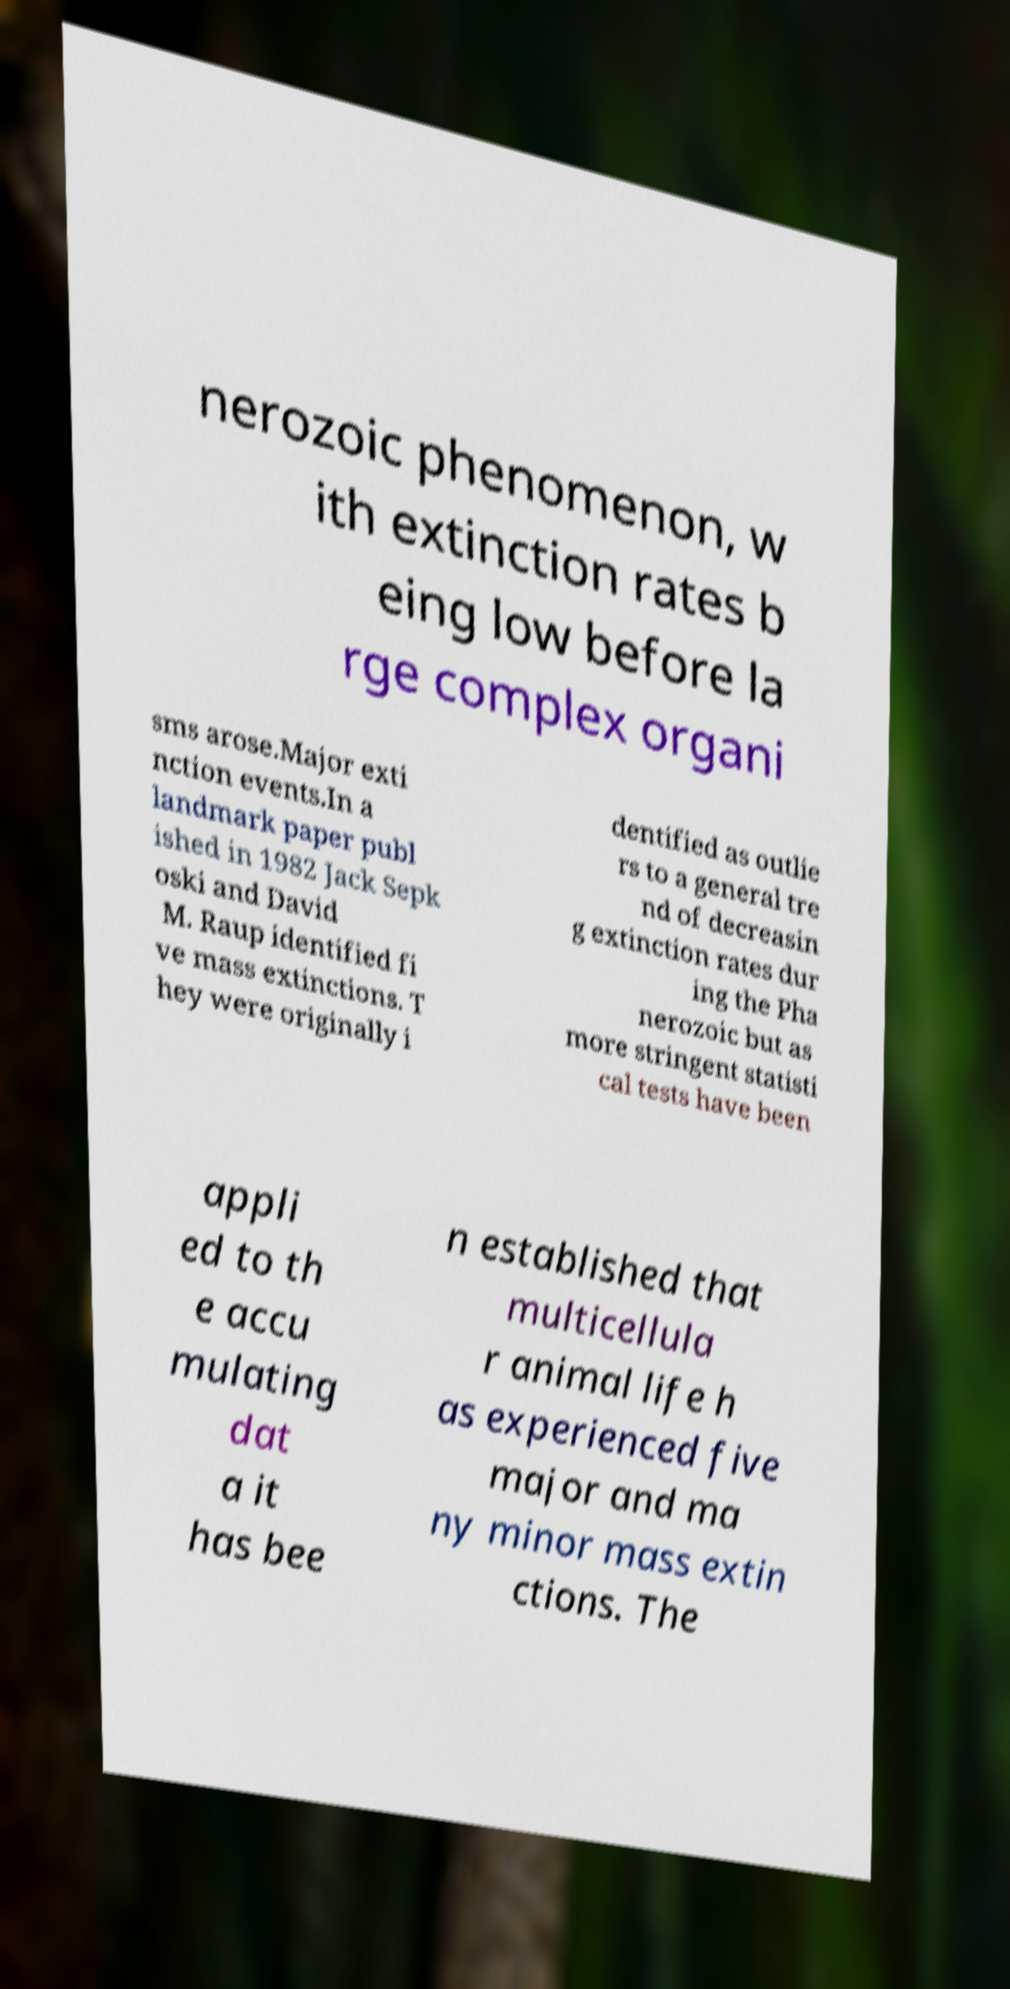Could you extract and type out the text from this image? nerozoic phenomenon, w ith extinction rates b eing low before la rge complex organi sms arose.Major exti nction events.In a landmark paper publ ished in 1982 Jack Sepk oski and David M. Raup identified fi ve mass extinctions. T hey were originally i dentified as outlie rs to a general tre nd of decreasin g extinction rates dur ing the Pha nerozoic but as more stringent statisti cal tests have been appli ed to th e accu mulating dat a it has bee n established that multicellula r animal life h as experienced five major and ma ny minor mass extin ctions. The 